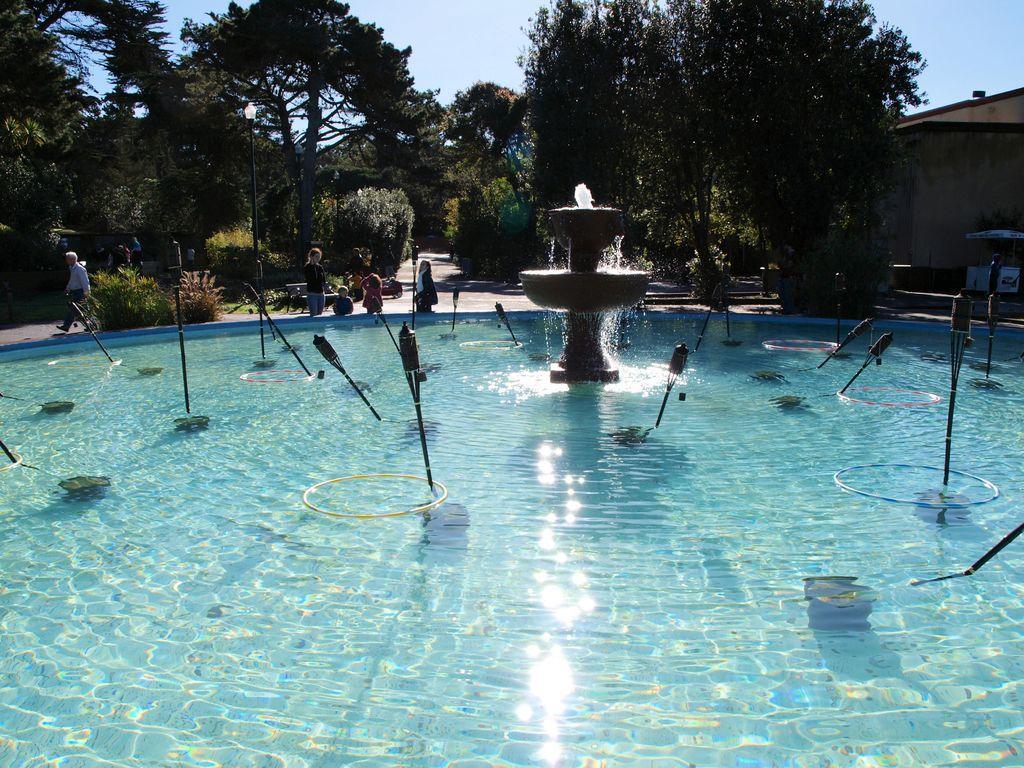Can you describe this image briefly? In this image I can see a swimming pool, poles, fountain and some objects. In the background I can see a group of people are standing and walking on the road, plants, light poles, trees, building, stall and the sky. This image is taken may be during a day. 